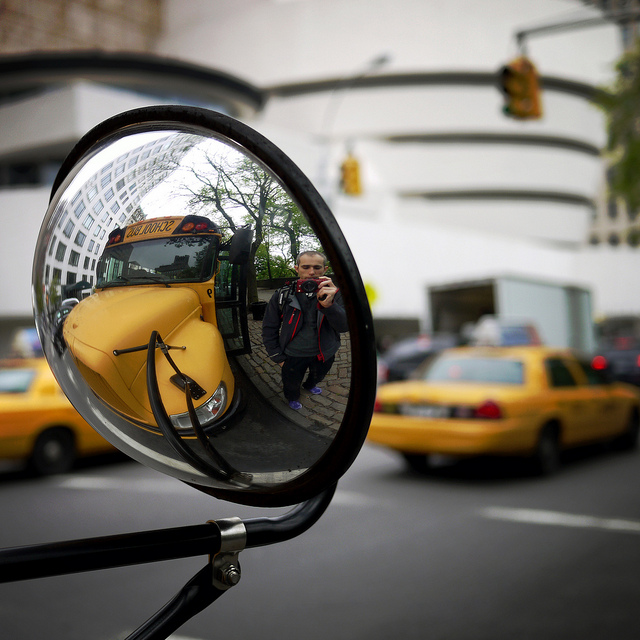Read all the text in this image. SCHOOL 